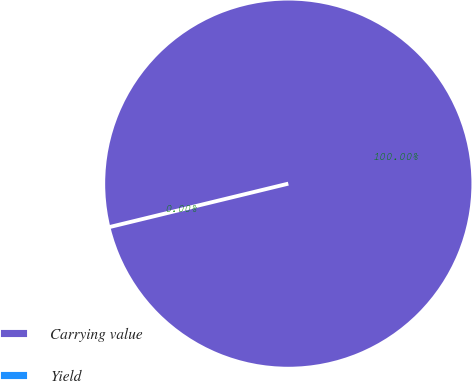<chart> <loc_0><loc_0><loc_500><loc_500><pie_chart><fcel>Carrying value<fcel>Yield<nl><fcel>100.0%<fcel>0.0%<nl></chart> 